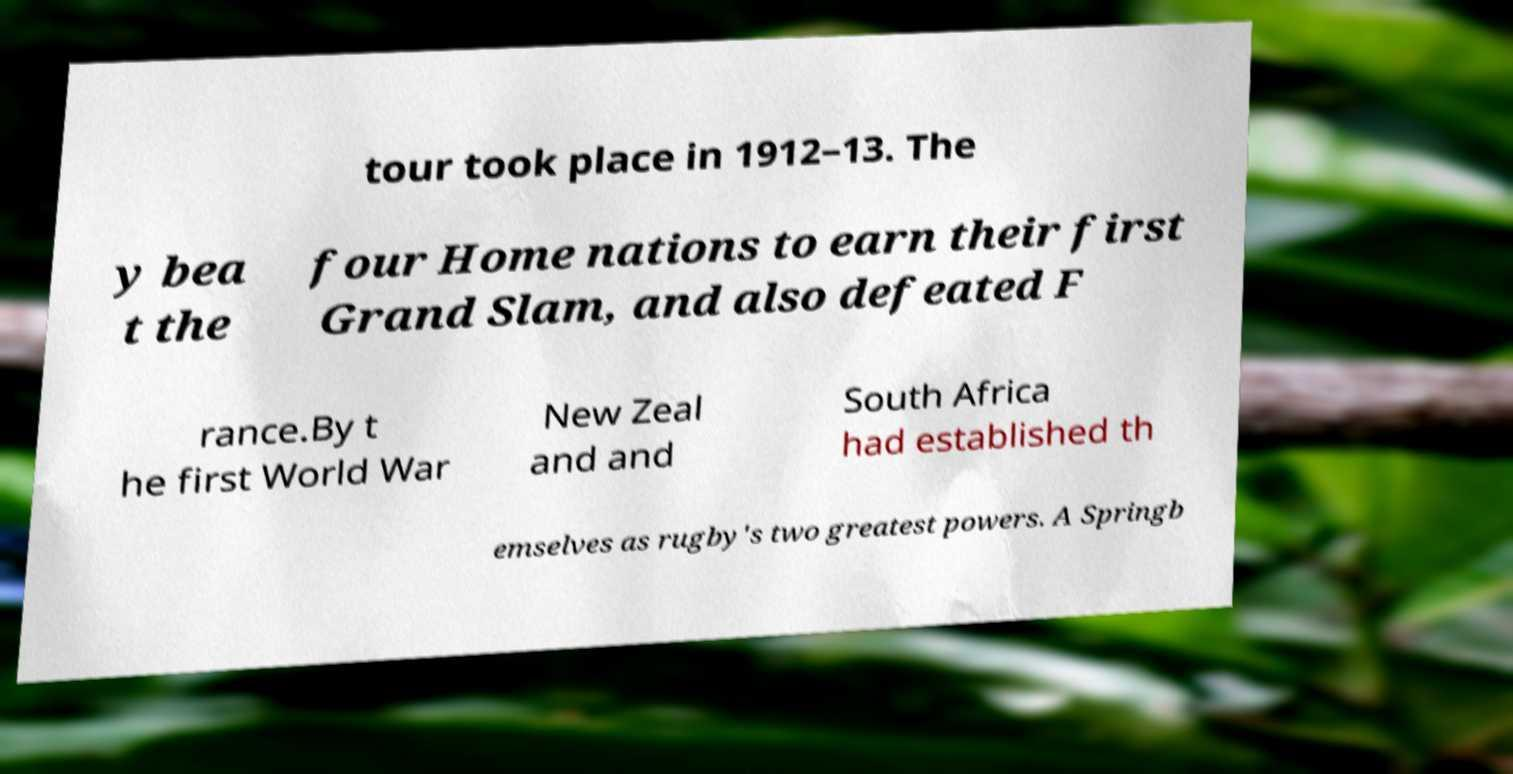What messages or text are displayed in this image? I need them in a readable, typed format. tour took place in 1912–13. The y bea t the four Home nations to earn their first Grand Slam, and also defeated F rance.By t he first World War New Zeal and and South Africa had established th emselves as rugby's two greatest powers. A Springb 